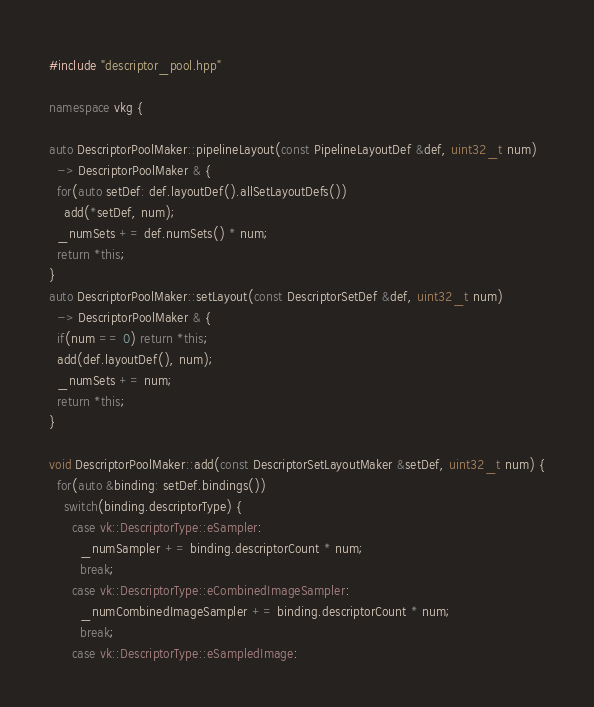<code> <loc_0><loc_0><loc_500><loc_500><_C++_>#include "descriptor_pool.hpp"

namespace vkg {

auto DescriptorPoolMaker::pipelineLayout(const PipelineLayoutDef &def, uint32_t num)
  -> DescriptorPoolMaker & {
  for(auto setDef: def.layoutDef().allSetLayoutDefs())
    add(*setDef, num);
  _numSets += def.numSets() * num;
  return *this;
}
auto DescriptorPoolMaker::setLayout(const DescriptorSetDef &def, uint32_t num)
  -> DescriptorPoolMaker & {
  if(num == 0) return *this;
  add(def.layoutDef(), num);
  _numSets += num;
  return *this;
}

void DescriptorPoolMaker::add(const DescriptorSetLayoutMaker &setDef, uint32_t num) {
  for(auto &binding: setDef.bindings())
    switch(binding.descriptorType) {
      case vk::DescriptorType::eSampler:
        _numSampler += binding.descriptorCount * num;
        break;
      case vk::DescriptorType::eCombinedImageSampler:
        _numCombinedImageSampler += binding.descriptorCount * num;
        break;
      case vk::DescriptorType::eSampledImage:</code> 